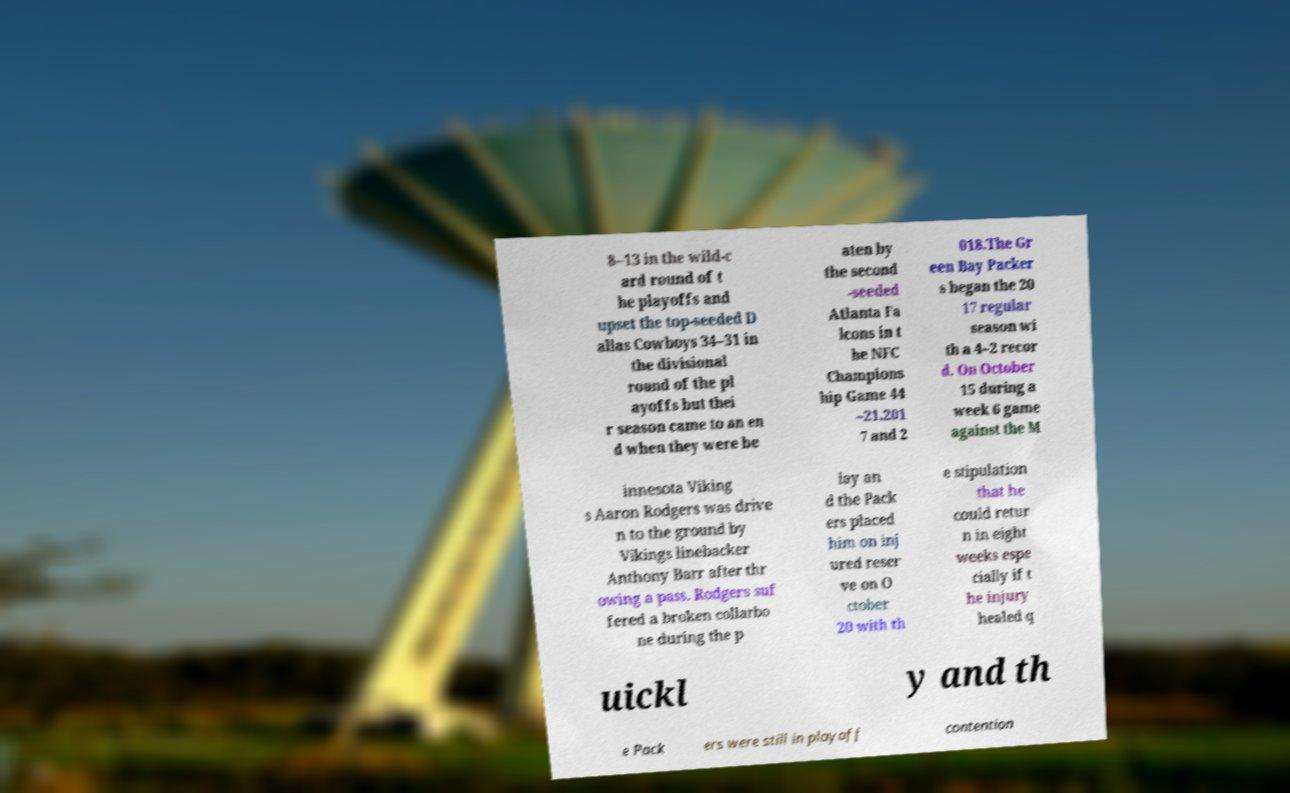Could you assist in decoding the text presented in this image and type it out clearly? 8–13 in the wild-c ard round of t he playoffs and upset the top-seeded D allas Cowboys 34–31 in the divisional round of the pl ayoffs but thei r season came to an en d when they were be aten by the second -seeded Atlanta Fa lcons in t he NFC Champions hip Game 44 –21.201 7 and 2 018.The Gr een Bay Packer s began the 20 17 regular season wi th a 4–2 recor d. On October 15 during a week 6 game against the M innesota Viking s Aaron Rodgers was drive n to the ground by Vikings linebacker Anthony Barr after thr owing a pass. Rodgers suf fered a broken collarbo ne during the p lay an d the Pack ers placed him on inj ured reser ve on O ctober 20 with th e stipulation that he could retur n in eight weeks espe cially if t he injury healed q uickl y and th e Pack ers were still in playoff contention 